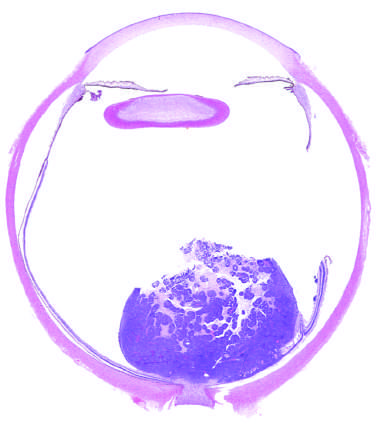s the poorly cohesive tumor in the retina seen abutting the optic nerve?
Answer the question using a single word or phrase. Yes 